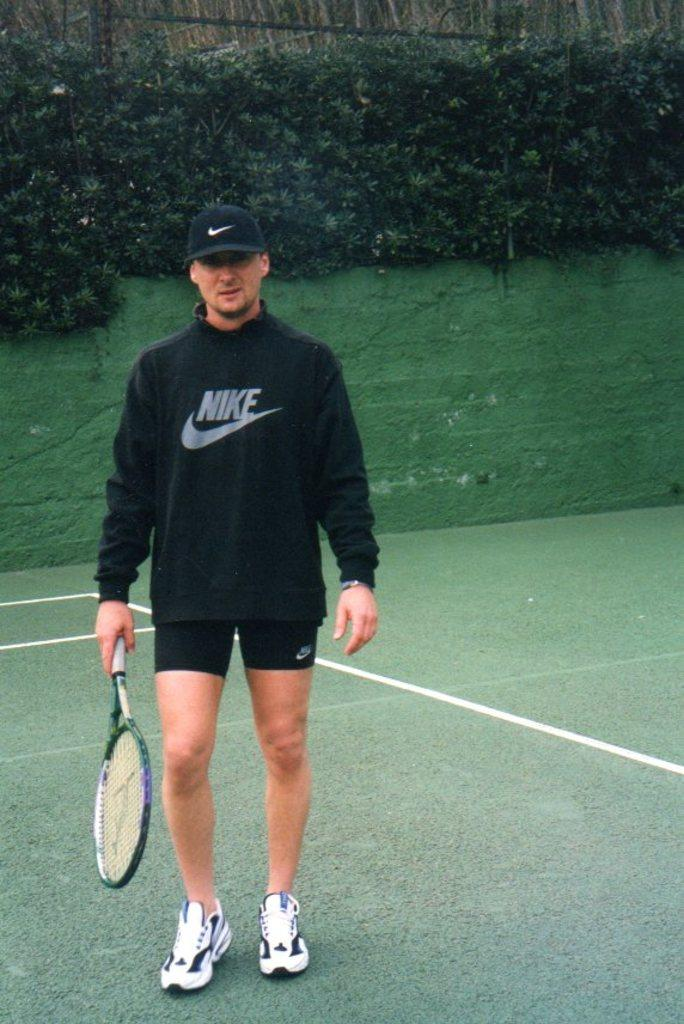Who is present in the image? There is a man in the image. What is the man holding in the image? The man is holding a bat. Where is the man located in the image? The man is on a path. What can be seen in the background of the image? There is a wall and plants in the background of the image. What type of rose is the man smelling in the image? There is no rose present in the image; it features a man holding a bat on a path with a wall and plants in the background. 